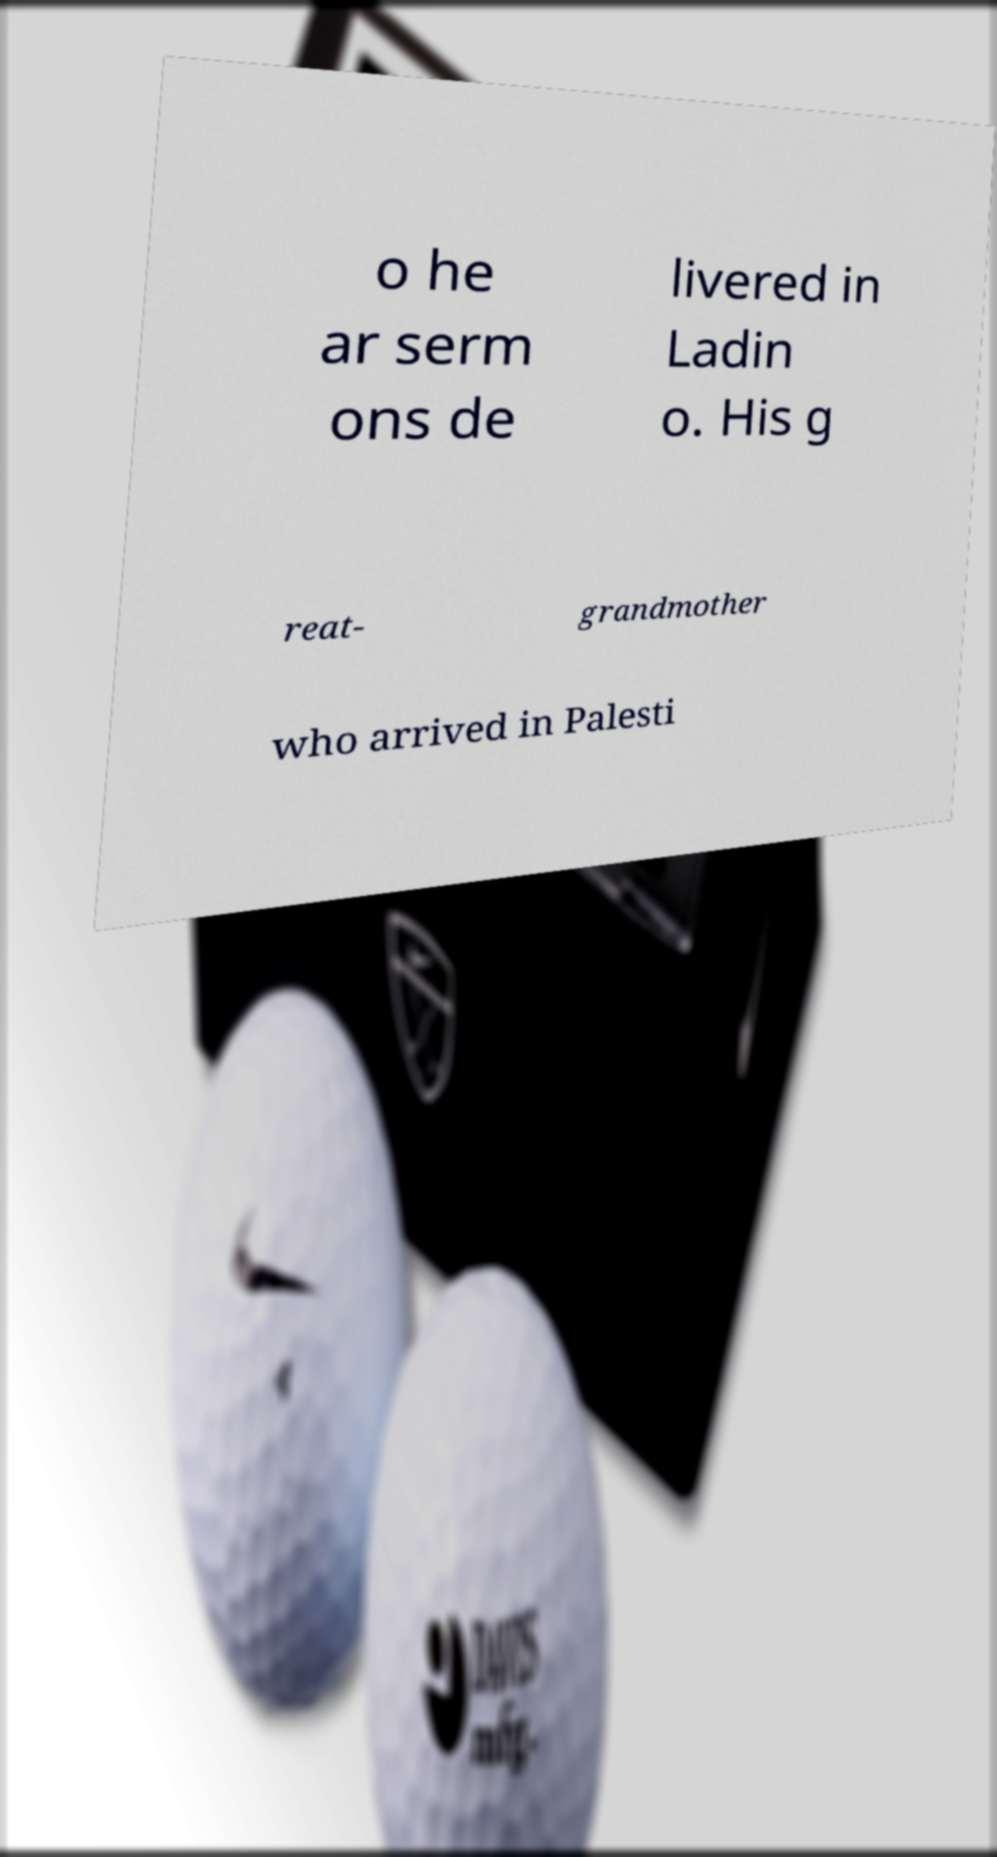There's text embedded in this image that I need extracted. Can you transcribe it verbatim? o he ar serm ons de livered in Ladin o. His g reat- grandmother who arrived in Palesti 